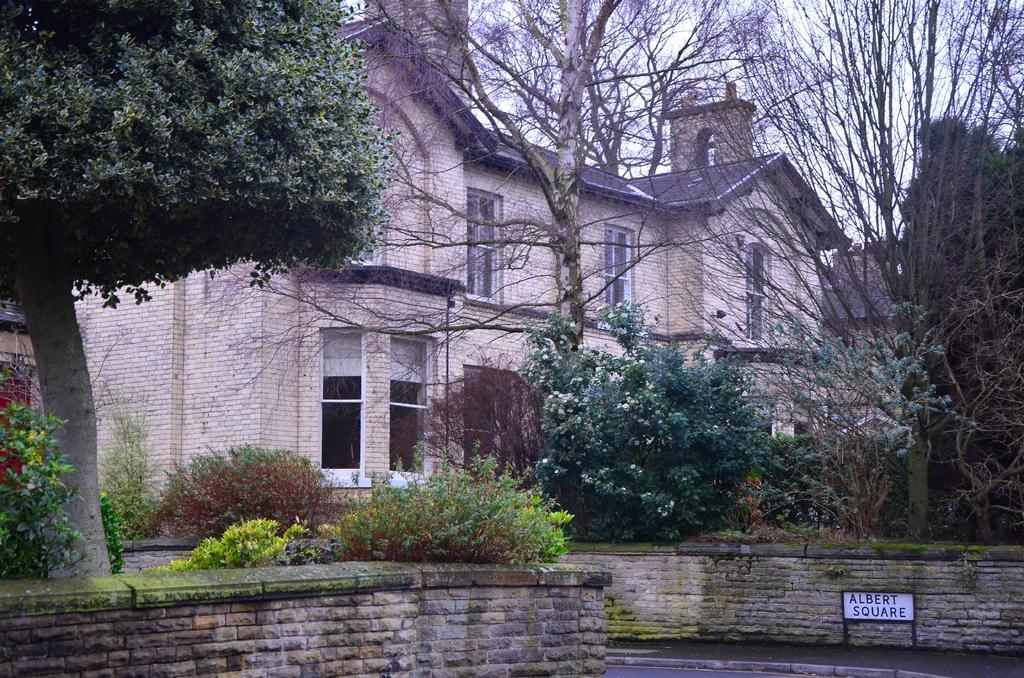Please provide a concise description of this image. In this picture we can see a board and in the background we can see a building, trees, plants and the sky. 